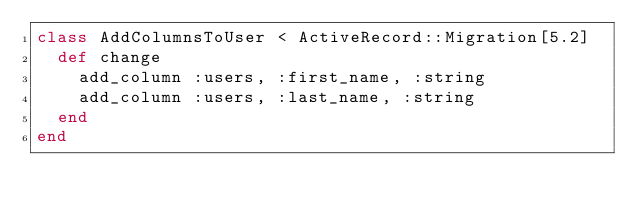<code> <loc_0><loc_0><loc_500><loc_500><_Ruby_>class AddColumnsToUser < ActiveRecord::Migration[5.2]
  def change
    add_column :users, :first_name, :string
    add_column :users, :last_name, :string
  end
end
</code> 